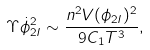<formula> <loc_0><loc_0><loc_500><loc_500>\Upsilon \dot { \phi } _ { 2 I } ^ { 2 } \sim \frac { n ^ { 2 } V ( \phi _ { 2 I } ) ^ { 2 } } { 9 C _ { 1 } T ^ { 3 } } ,</formula> 